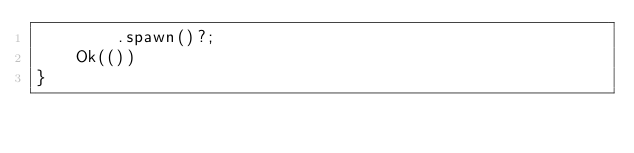Convert code to text. <code><loc_0><loc_0><loc_500><loc_500><_Rust_>        .spawn()?;
    Ok(())
}
</code> 